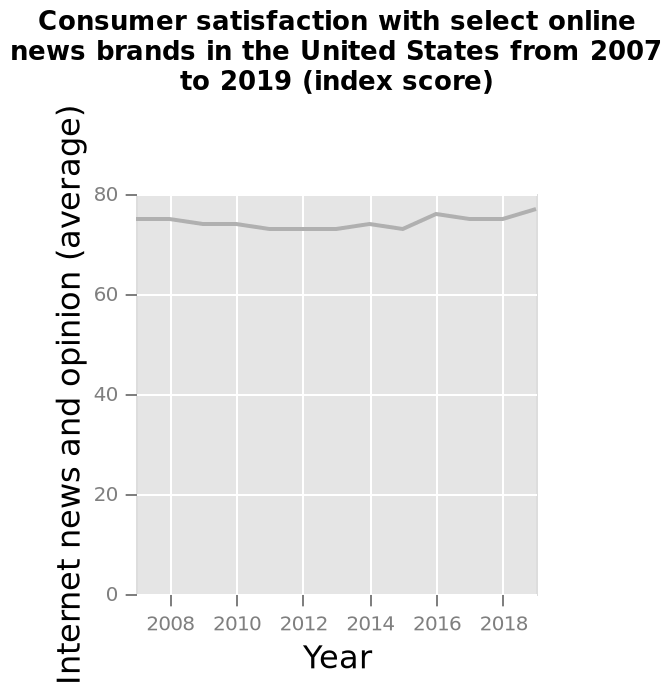<image>
What does the y-axis measure on the line graph?  The y-axis measures Internet news and opinion (average). Has satisfaction remained constant over the years? Satisfaction has remained pretty stable for the most part, with slight ups and downs in particular years. 